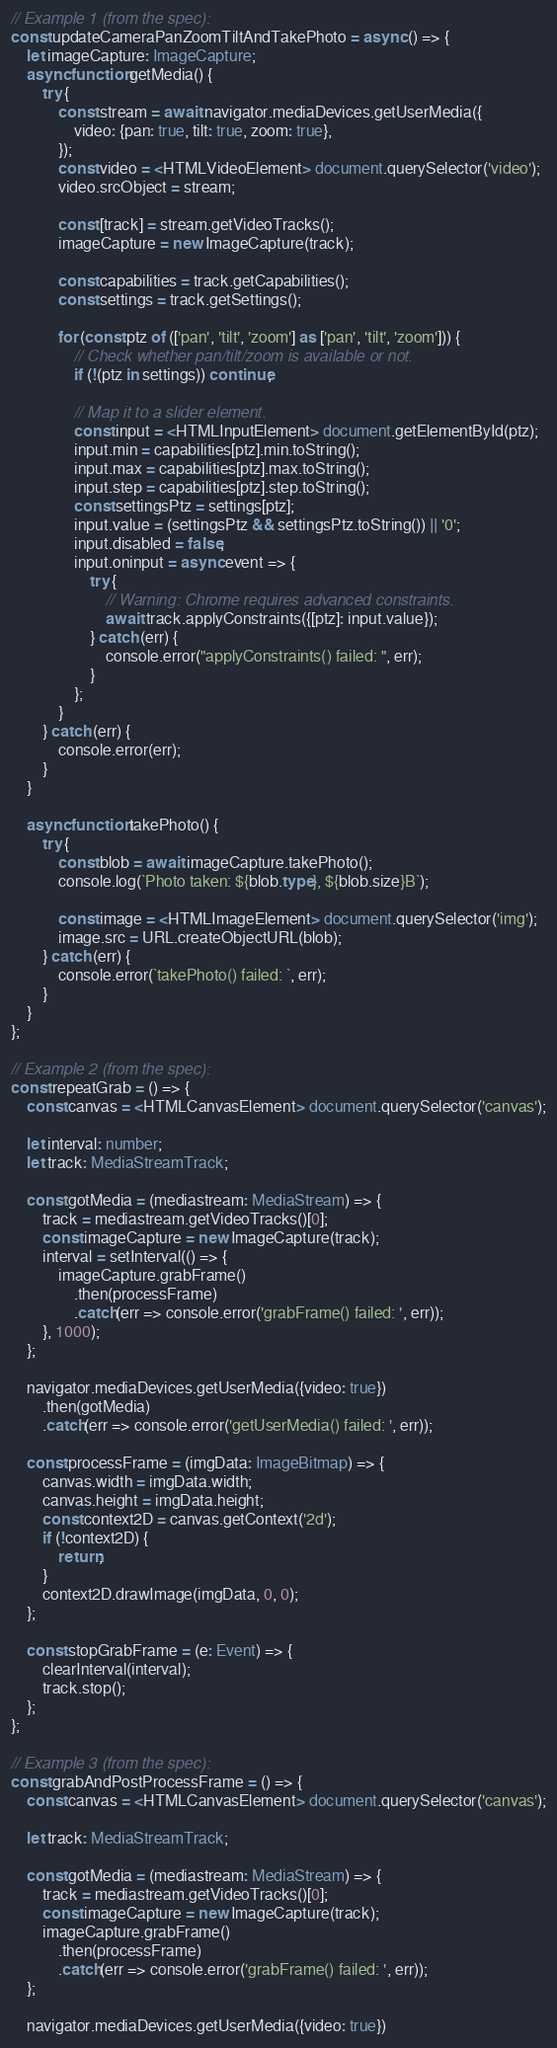<code> <loc_0><loc_0><loc_500><loc_500><_TypeScript_>// Example 1 (from the spec):
const updateCameraPanZoomTiltAndTakePhoto = async () => {
    let imageCapture: ImageCapture;
    async function getMedia() {
        try {
            const stream = await navigator.mediaDevices.getUserMedia({
                video: {pan: true, tilt: true, zoom: true},
            });
            const video = <HTMLVideoElement> document.querySelector('video');
            video.srcObject = stream;

            const [track] = stream.getVideoTracks();
            imageCapture = new ImageCapture(track);

            const capabilities = track.getCapabilities();
            const settings = track.getSettings();

            for (const ptz of (['pan', 'tilt', 'zoom'] as ['pan', 'tilt', 'zoom'])) {
                // Check whether pan/tilt/zoom is available or not.
                if (!(ptz in settings)) continue;

                // Map it to a slider element.
                const input = <HTMLInputElement> document.getElementById(ptz);
                input.min = capabilities[ptz].min.toString();
                input.max = capabilities[ptz].max.toString();
                input.step = capabilities[ptz].step.toString();
                const settingsPtz = settings[ptz];
                input.value = (settingsPtz && settingsPtz.toString()) || '0';
                input.disabled = false;
                input.oninput = async event => {
                    try {
                        // Warning: Chrome requires advanced constraints.
                        await track.applyConstraints({[ptz]: input.value});
                    } catch (err) {
                        console.error("applyConstraints() failed: ", err);
                    }
                };
            }
        } catch (err) {
            console.error(err);
        }
    }

    async function takePhoto() {
        try {
            const blob = await imageCapture.takePhoto();
            console.log(`Photo taken: ${blob.type}, ${blob.size}B`);

            const image = <HTMLImageElement> document.querySelector('img');
            image.src = URL.createObjectURL(blob);
        } catch (err) {
            console.error(`takePhoto() failed: `, err);
        }
    }
};

// Example 2 (from the spec):
const repeatGrab = () => {
    const canvas = <HTMLCanvasElement> document.querySelector('canvas');

    let interval: number;
    let track: MediaStreamTrack;

    const gotMedia = (mediastream: MediaStream) => {
        track = mediastream.getVideoTracks()[0];
        const imageCapture = new ImageCapture(track);
        interval = setInterval(() => {
            imageCapture.grabFrame()
                .then(processFrame)
                .catch(err => console.error('grabFrame() failed: ', err));
        }, 1000);
    };

    navigator.mediaDevices.getUserMedia({video: true})
        .then(gotMedia)
        .catch(err => console.error('getUserMedia() failed: ', err));

    const processFrame = (imgData: ImageBitmap) => {
        canvas.width = imgData.width;
        canvas.height = imgData.height;
        const context2D = canvas.getContext('2d');
        if (!context2D) {
            return;
        }
        context2D.drawImage(imgData, 0, 0);
    };

    const stopGrabFrame = (e: Event) => {
        clearInterval(interval);
        track.stop();
    };
};

// Example 3 (from the spec):
const grabAndPostProcessFrame = () => {
    const canvas = <HTMLCanvasElement> document.querySelector('canvas');

    let track: MediaStreamTrack;

    const gotMedia = (mediastream: MediaStream) => {
        track = mediastream.getVideoTracks()[0];
        const imageCapture = new ImageCapture(track);
        imageCapture.grabFrame()
            .then(processFrame)
            .catch(err => console.error('grabFrame() failed: ', err));
    };

    navigator.mediaDevices.getUserMedia({video: true})</code> 